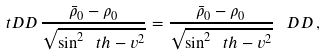Convert formula to latex. <formula><loc_0><loc_0><loc_500><loc_500>\ t D D \, \frac { \bar { \rho } _ { 0 } - \rho _ { 0 } } { \sqrt { \sin ^ { 2 } \ t h - v ^ { 2 } } } = \frac { \bar { \rho } _ { 0 } - \rho _ { 0 } } { \sqrt { \sin ^ { 2 } \ t h - v ^ { 2 } } } \, \ D D \, ,</formula> 